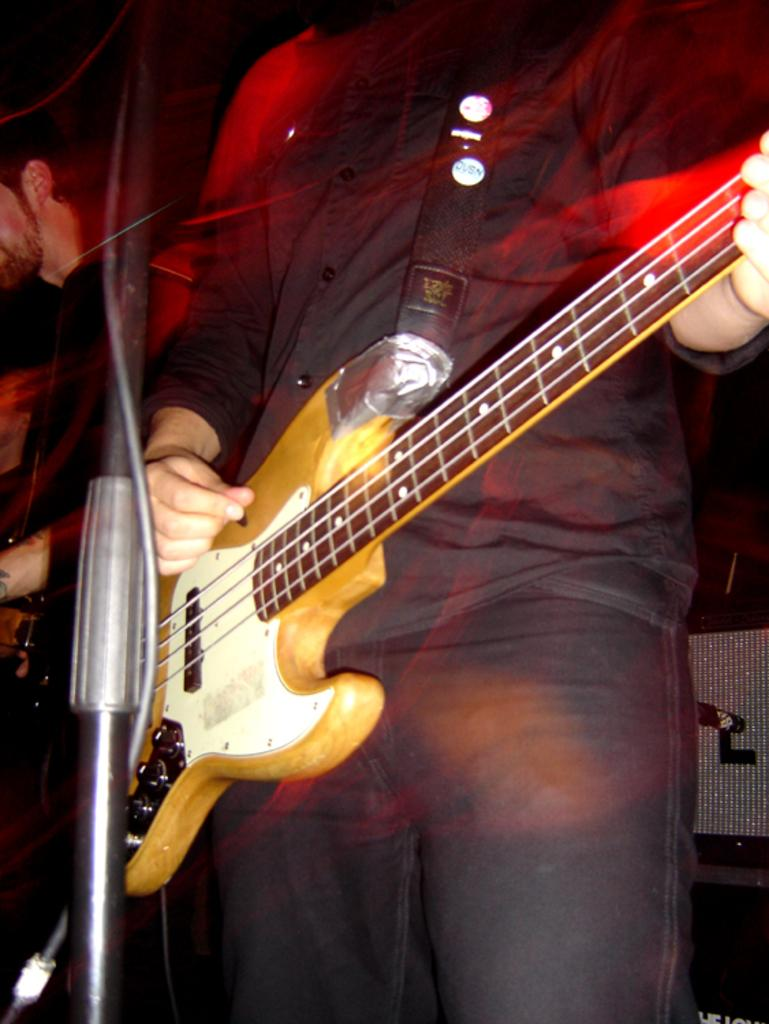What is the main subject of the image? There is a person standing and playing a guitar in the center of the image. What is in front of the person playing the guitar? There is a stand in front of the person playing the guitar. What can be seen in the background of the image? There is a wall in the background of the image. Are there any other people visible in the image? Yes, there is another person standing in the background of the image. What type of truck can be seen in the image? There is no truck present in the image. What hobbies does the person playing the guitar have, based on the image? The image only shows the person playing the guitar, so we cannot determine any other hobbies they might have. 